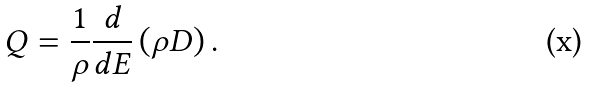<formula> <loc_0><loc_0><loc_500><loc_500>Q = \frac { 1 } { \rho } \frac { d } { d E } \left ( { \rho D } \right ) .</formula> 